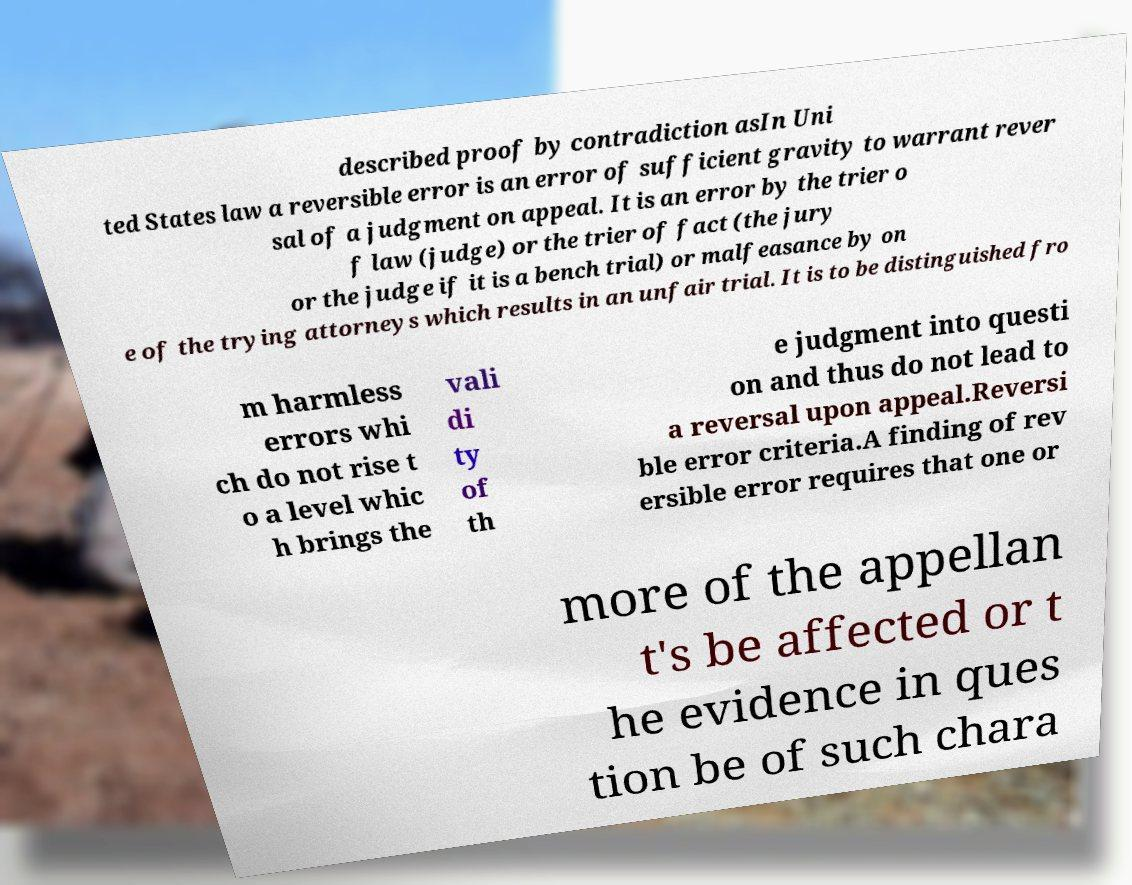What messages or text are displayed in this image? I need them in a readable, typed format. described proof by contradiction asIn Uni ted States law a reversible error is an error of sufficient gravity to warrant rever sal of a judgment on appeal. It is an error by the trier o f law (judge) or the trier of fact (the jury or the judge if it is a bench trial) or malfeasance by on e of the trying attorneys which results in an unfair trial. It is to be distinguished fro m harmless errors whi ch do not rise t o a level whic h brings the vali di ty of th e judgment into questi on and thus do not lead to a reversal upon appeal.Reversi ble error criteria.A finding of rev ersible error requires that one or more of the appellan t's be affected or t he evidence in ques tion be of such chara 